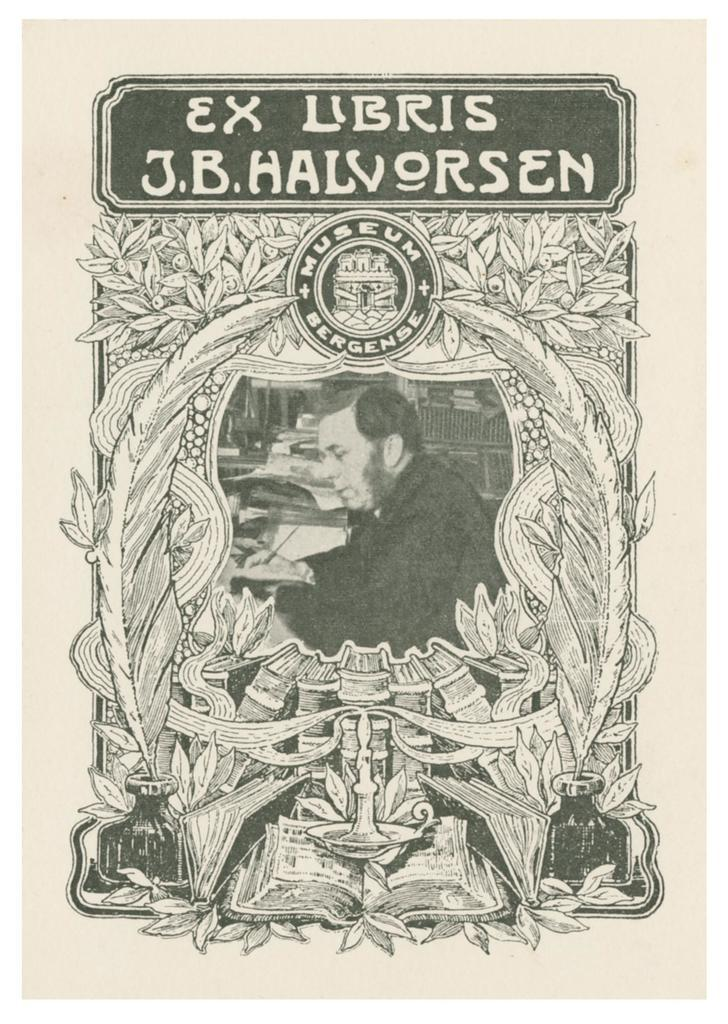Provide a one-sentence caption for the provided image. A black and white museum poster contains the name J.B. Halvorsen near the top. 